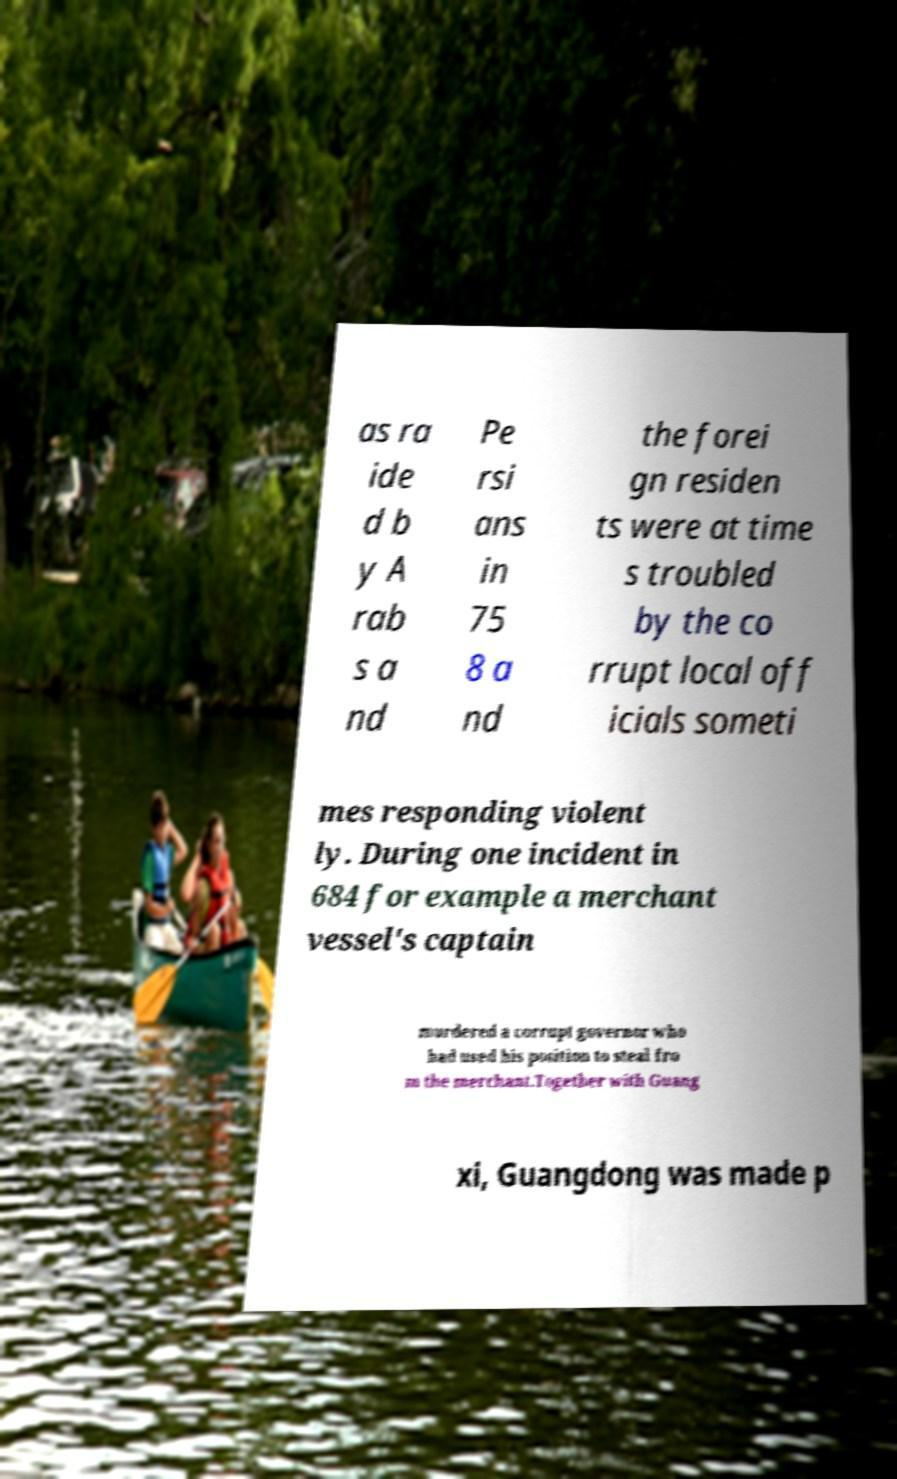Could you assist in decoding the text presented in this image and type it out clearly? as ra ide d b y A rab s a nd Pe rsi ans in 75 8 a nd the forei gn residen ts were at time s troubled by the co rrupt local off icials someti mes responding violent ly. During one incident in 684 for example a merchant vessel's captain murdered a corrupt governor who had used his position to steal fro m the merchant.Together with Guang xi, Guangdong was made p 